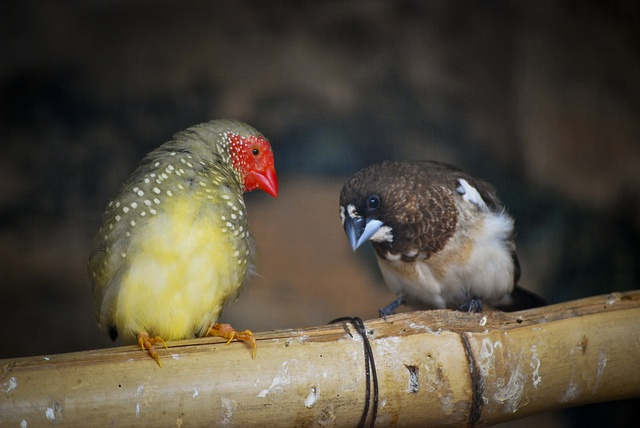Describe the objects in this image and their specific colors. I can see bird in black, tan, gray, and khaki tones and bird in black, gray, and darkgray tones in this image. 